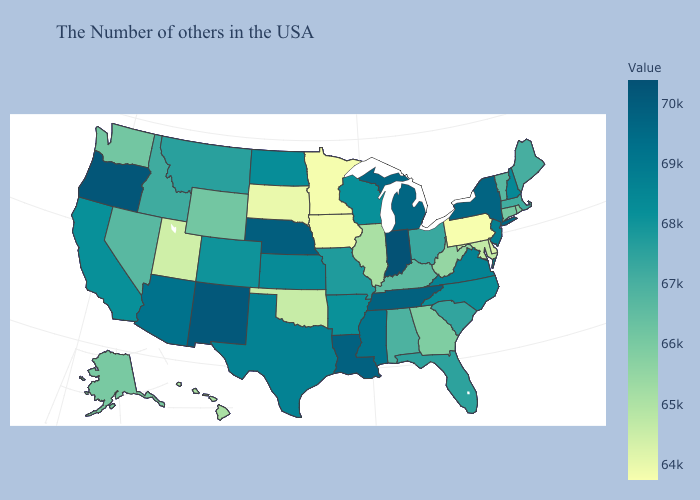Which states hav the highest value in the South?
Write a very short answer. Tennessee. Which states have the lowest value in the Northeast?
Answer briefly. Pennsylvania. Is the legend a continuous bar?
Answer briefly. Yes. Does Maryland have the lowest value in the South?
Keep it brief. No. Which states have the lowest value in the USA?
Concise answer only. Pennsylvania. Does Washington have the lowest value in the USA?
Quick response, please. No. 